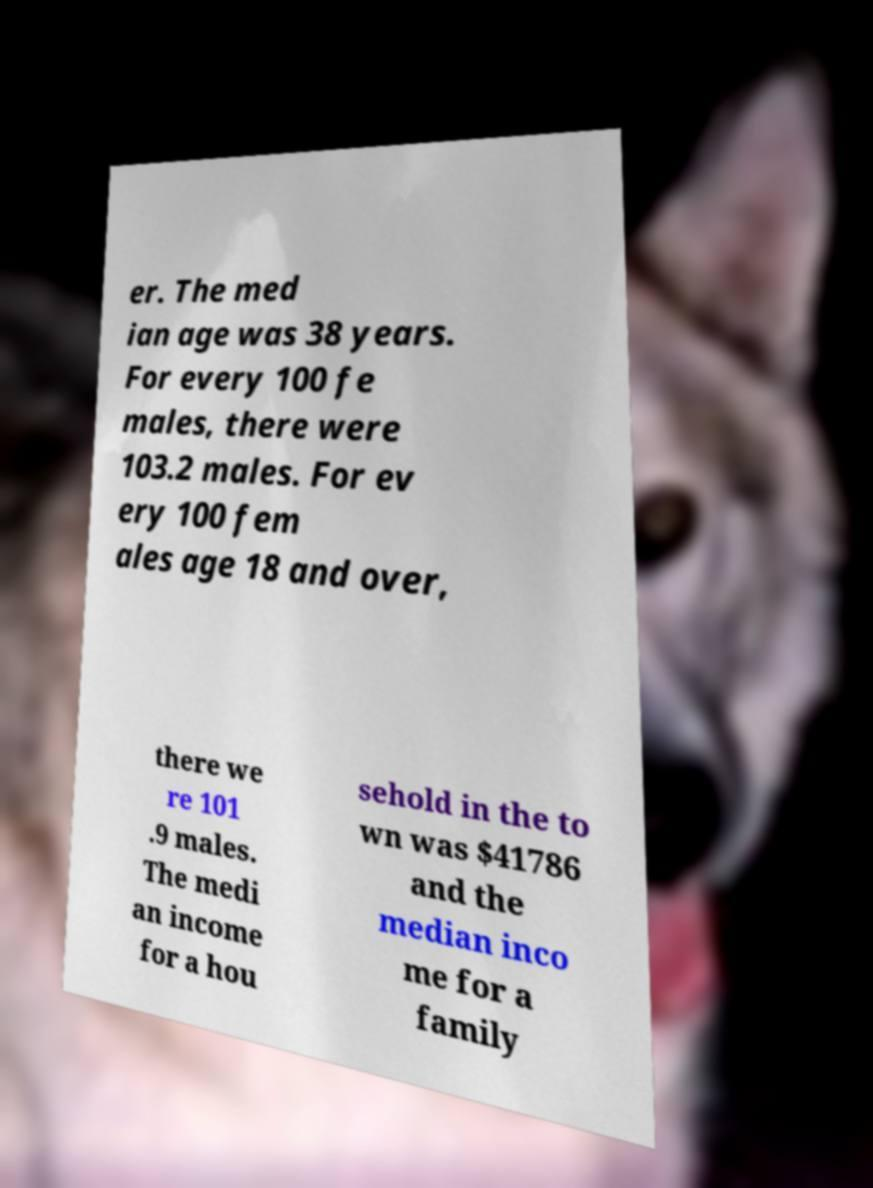Could you extract and type out the text from this image? er. The med ian age was 38 years. For every 100 fe males, there were 103.2 males. For ev ery 100 fem ales age 18 and over, there we re 101 .9 males. The medi an income for a hou sehold in the to wn was $41786 and the median inco me for a family 